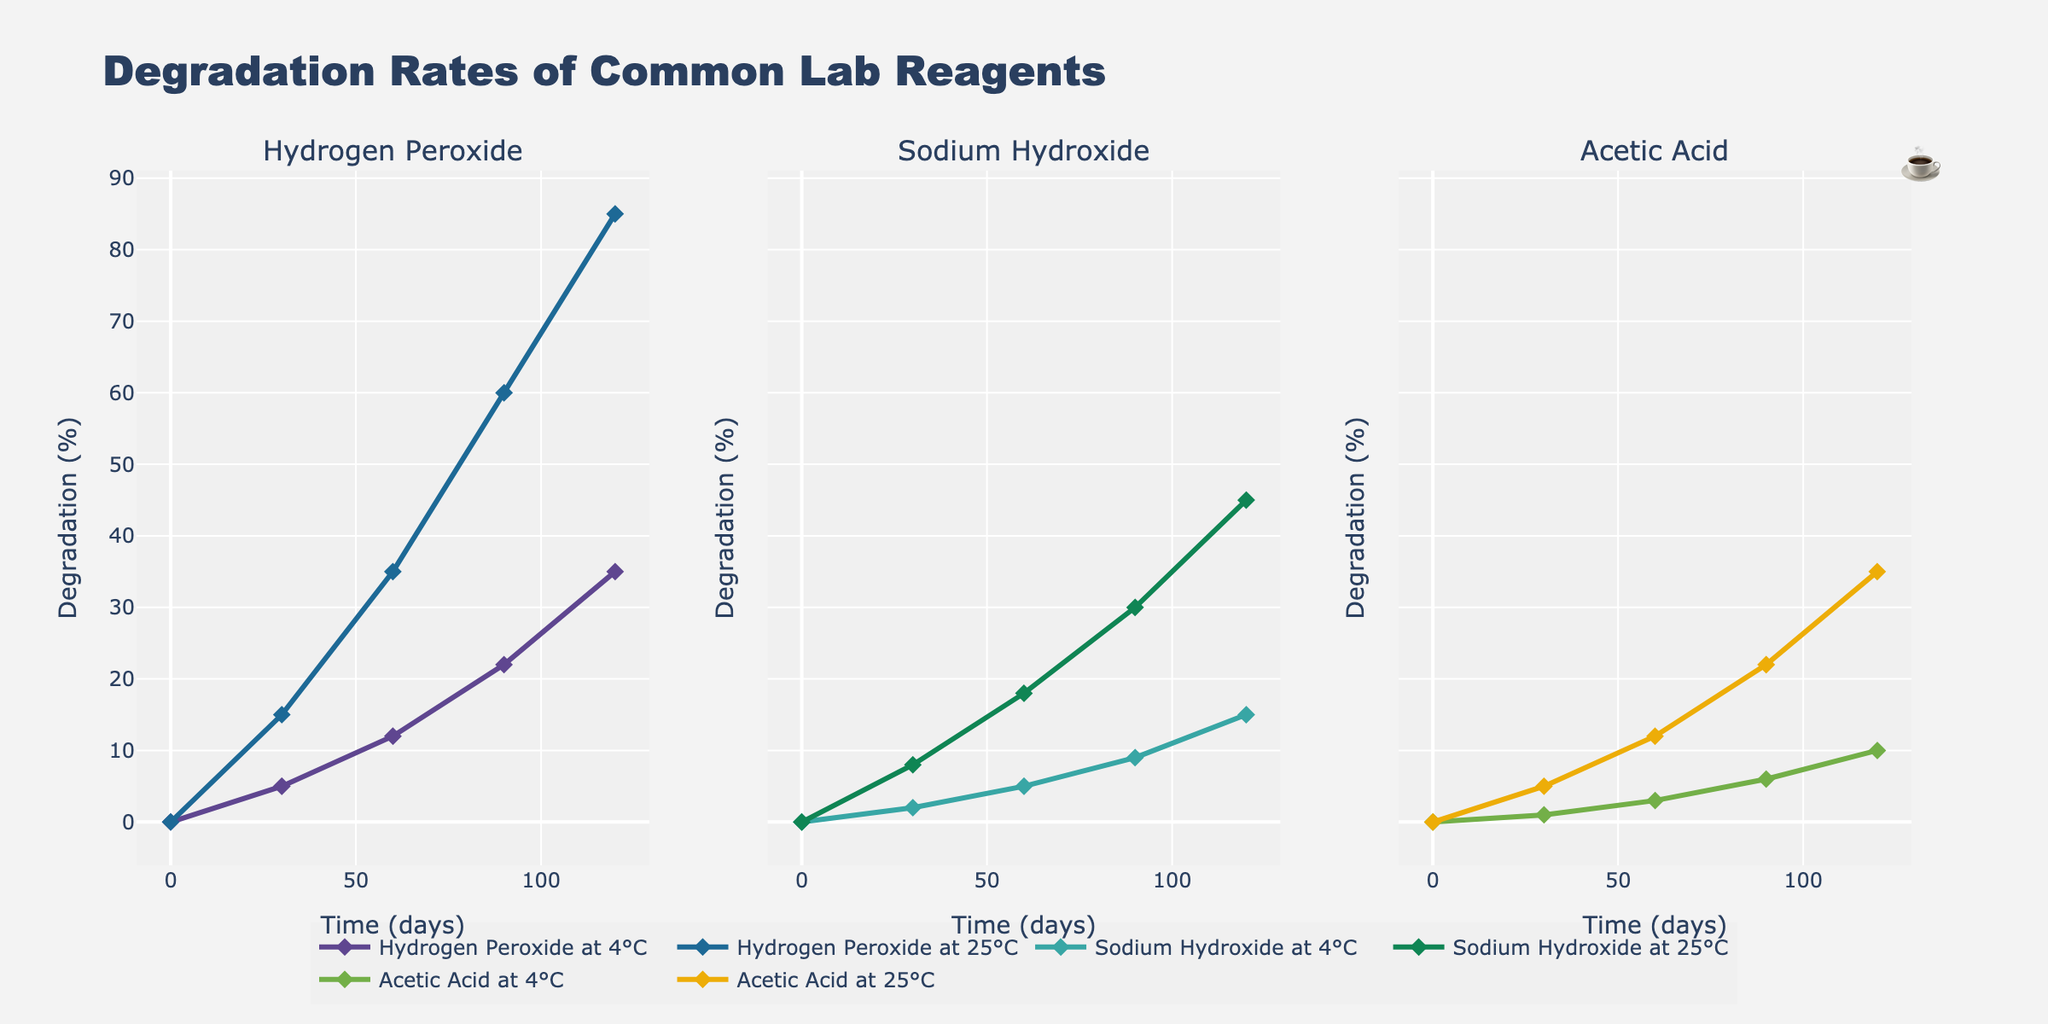Which reagent has the highest degradation rate at 25°C after 90 days? By comparing the degradation rates at 25°C for each reagent after 90 days, we find that Hydrogen Peroxide has a degradation rate of 60%, Sodium Hydroxide has 30%, and Acetic Acid has 22%. Therefore, Hydrogen Peroxide has the highest degradation rate.
Answer: Hydrogen Peroxide Which temperature causes a higher degradation rate for Hydrogen Peroxide at the 60-day mark? By looking at the degradation rates for Hydrogen Peroxide at both 4°C and 25°C after 60 days, we see that at 4°C the degradation rate is 12%, and at 25°C, it's 35%. Thus, 25°C causes a higher degradation rate.
Answer: 25°C What is the total degradation of Acetic Acid at both temperatures after 120 days? For Acetic Acid, the degradation at 4°C after 120 days is 10%, and at 25°C it is 35%. Summing these gives 10% + 35% = 45%.
Answer: 45% Which reagent shows the least change in degradation percentage from 0 to 60 days at 4°C? By comparing the degradation percentages for each reagent at 4°C between 0 and 60 days, we see that Hydrogen Peroxide increases by 12%, Sodium Hydroxide by 5%, and Acetic Acid by 3%. Acetic Acid shows the least change.
Answer: Acetic Acid How does the degradation rate of Sodium Hydroxide at 25°C compare to its rate at 4°C after 30 days? At 25°C, Sodium Hydroxide has a degradation rate of 8% after 30 days. At 4°C, it is 2%. So, the degradation rate at 25°C is higher.
Answer: 25°C is higher What is the average degradation of all reagents at 25°C on the 60th day? Adding the degradation percentages of all reagents at 25°C on the 60th day: Hydrogen Peroxide (35%), Sodium Hydroxide (18%), and Acetic Acid (12%). Their average is (35% + 18% + 12%) / 3 = 21.67%.
Answer: 21.67% Which reagent has the smallest increase in degradation when moving from 30 to 90 days at 4°C? By evaluating the increases for each reagent at 4°C from 30 to 90 days, we find Hydrogen Peroxide increases by 17% (22% - 5%), Sodium Hydroxide by 7% (9% - 2%), and Acetic Acid by 5% (6% - 1%). Acetic Acid has the smallest increase.
Answer: Acetic Acid At 4°C, which reagent has the least degradation percentage at the 120-day mark? By comparing the degradation percentages at 4°C for 120 days, we see that Hydrogen Peroxide is at 35%, Sodium Hydroxide at 15%, and Acetic Acid at 10%. Acetic Acid has the least degradation percentage.
Answer: Acetic Acid 